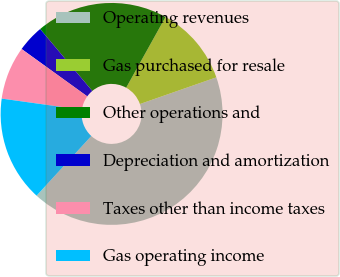<chart> <loc_0><loc_0><loc_500><loc_500><pie_chart><fcel>Operating revenues<fcel>Gas purchased for resale<fcel>Other operations and<fcel>Depreciation and amortization<fcel>Taxes other than income taxes<fcel>Gas operating income<nl><fcel>42.16%<fcel>11.57%<fcel>19.22%<fcel>3.92%<fcel>7.74%<fcel>15.39%<nl></chart> 